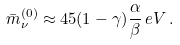<formula> <loc_0><loc_0><loc_500><loc_500>\bar { m } _ { \nu } ^ { ( 0 ) } \approx 4 5 ( 1 - \gamma ) \frac { \alpha } { \beta } \, e V \, .</formula> 